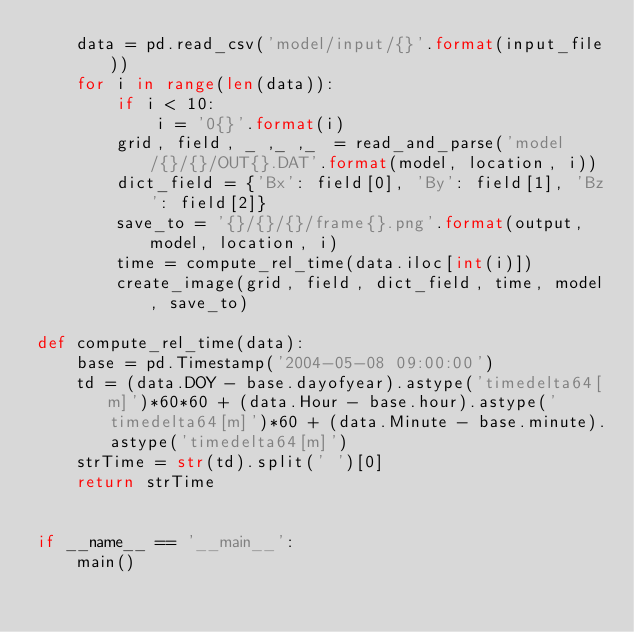Convert code to text. <code><loc_0><loc_0><loc_500><loc_500><_Python_>    data = pd.read_csv('model/input/{}'.format(input_file))
    for i in range(len(data)):
        if i < 10:
            i = '0{}'.format(i)
        grid, field, _ ,_ ,_  = read_and_parse('model/{}/{}/OUT{}.DAT'.format(model, location, i))
        dict_field = {'Bx': field[0], 'By': field[1], 'Bz': field[2]}
        save_to = '{}/{}/{}/frame{}.png'.format(output, model, location, i)
        time = compute_rel_time(data.iloc[int(i)])
        create_image(grid, field, dict_field, time, model, save_to)

def compute_rel_time(data):
    base = pd.Timestamp('2004-05-08 09:00:00')
    td = (data.DOY - base.dayofyear).astype('timedelta64[m]')*60*60 + (data.Hour - base.hour).astype('timedelta64[m]')*60 + (data.Minute - base.minute).astype('timedelta64[m]')
    strTime = str(td).split(' ')[0]
    return strTime


if __name__ == '__main__':
    main()

</code> 